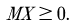Convert formula to latex. <formula><loc_0><loc_0><loc_500><loc_500>M X \geq 0 .</formula> 